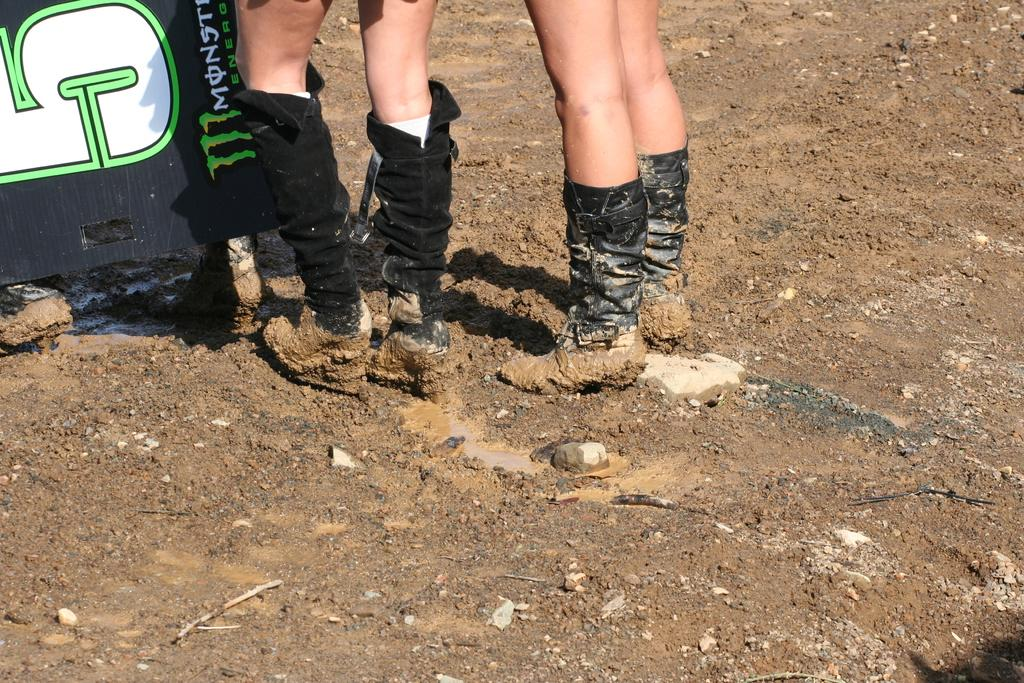What body parts can be seen in the image? There are people's legs visible in the image. What object is present for displaying information or messages? There is a text board in the image. What natural element is visible in the image? There is water visible in the image. What type of surface is present in the image? Stones and soil are visible in the image. What type of tree can be seen in the image? There is no tree present in the image. What kind of apparel are the people wearing in the image? The provided facts do not mention any apparel worn by the people in the image. 